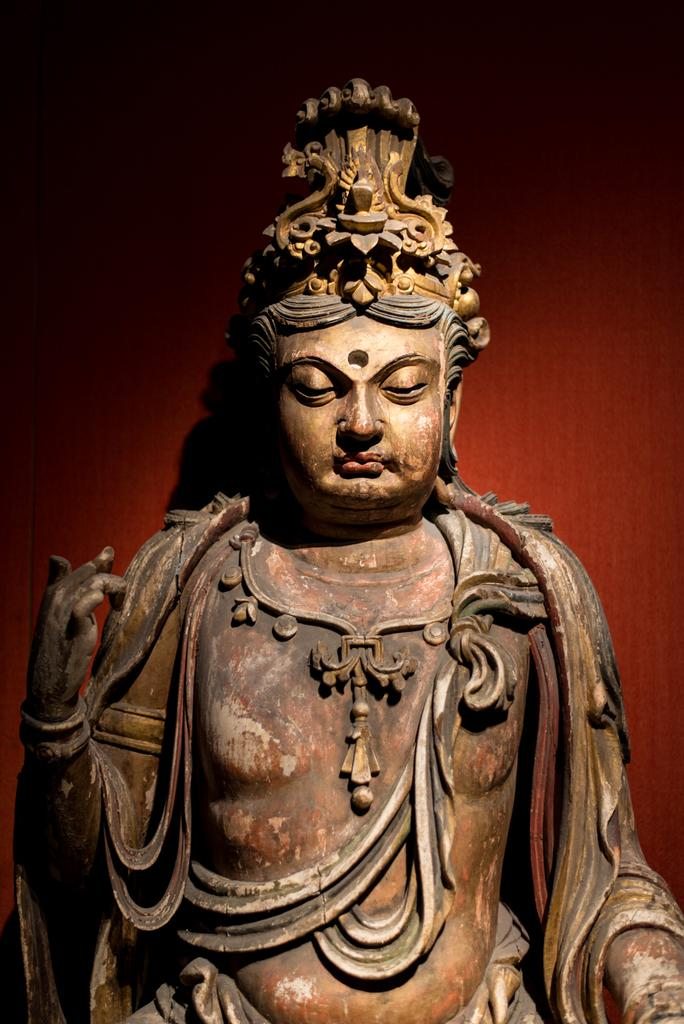What is the main subject of the image? There is a sculpture in the image. What color is the background of the image? The background of the image is red. What grade is the mitten in the image? There is no mitten present in the image. What type of train can be seen in the image? There is no train present in the image. 